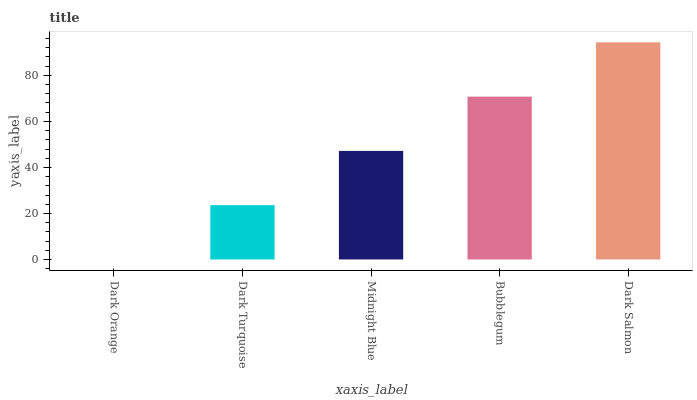Is Dark Orange the minimum?
Answer yes or no. Yes. Is Dark Salmon the maximum?
Answer yes or no. Yes. Is Dark Turquoise the minimum?
Answer yes or no. No. Is Dark Turquoise the maximum?
Answer yes or no. No. Is Dark Turquoise greater than Dark Orange?
Answer yes or no. Yes. Is Dark Orange less than Dark Turquoise?
Answer yes or no. Yes. Is Dark Orange greater than Dark Turquoise?
Answer yes or no. No. Is Dark Turquoise less than Dark Orange?
Answer yes or no. No. Is Midnight Blue the high median?
Answer yes or no. Yes. Is Midnight Blue the low median?
Answer yes or no. Yes. Is Bubblegum the high median?
Answer yes or no. No. Is Bubblegum the low median?
Answer yes or no. No. 